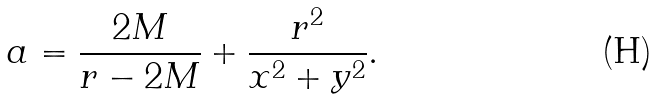<formula> <loc_0><loc_0><loc_500><loc_500>a = \frac { 2 M } { r - 2 M } + \frac { r ^ { 2 } } { x ^ { 2 } + y ^ { 2 } } .</formula> 